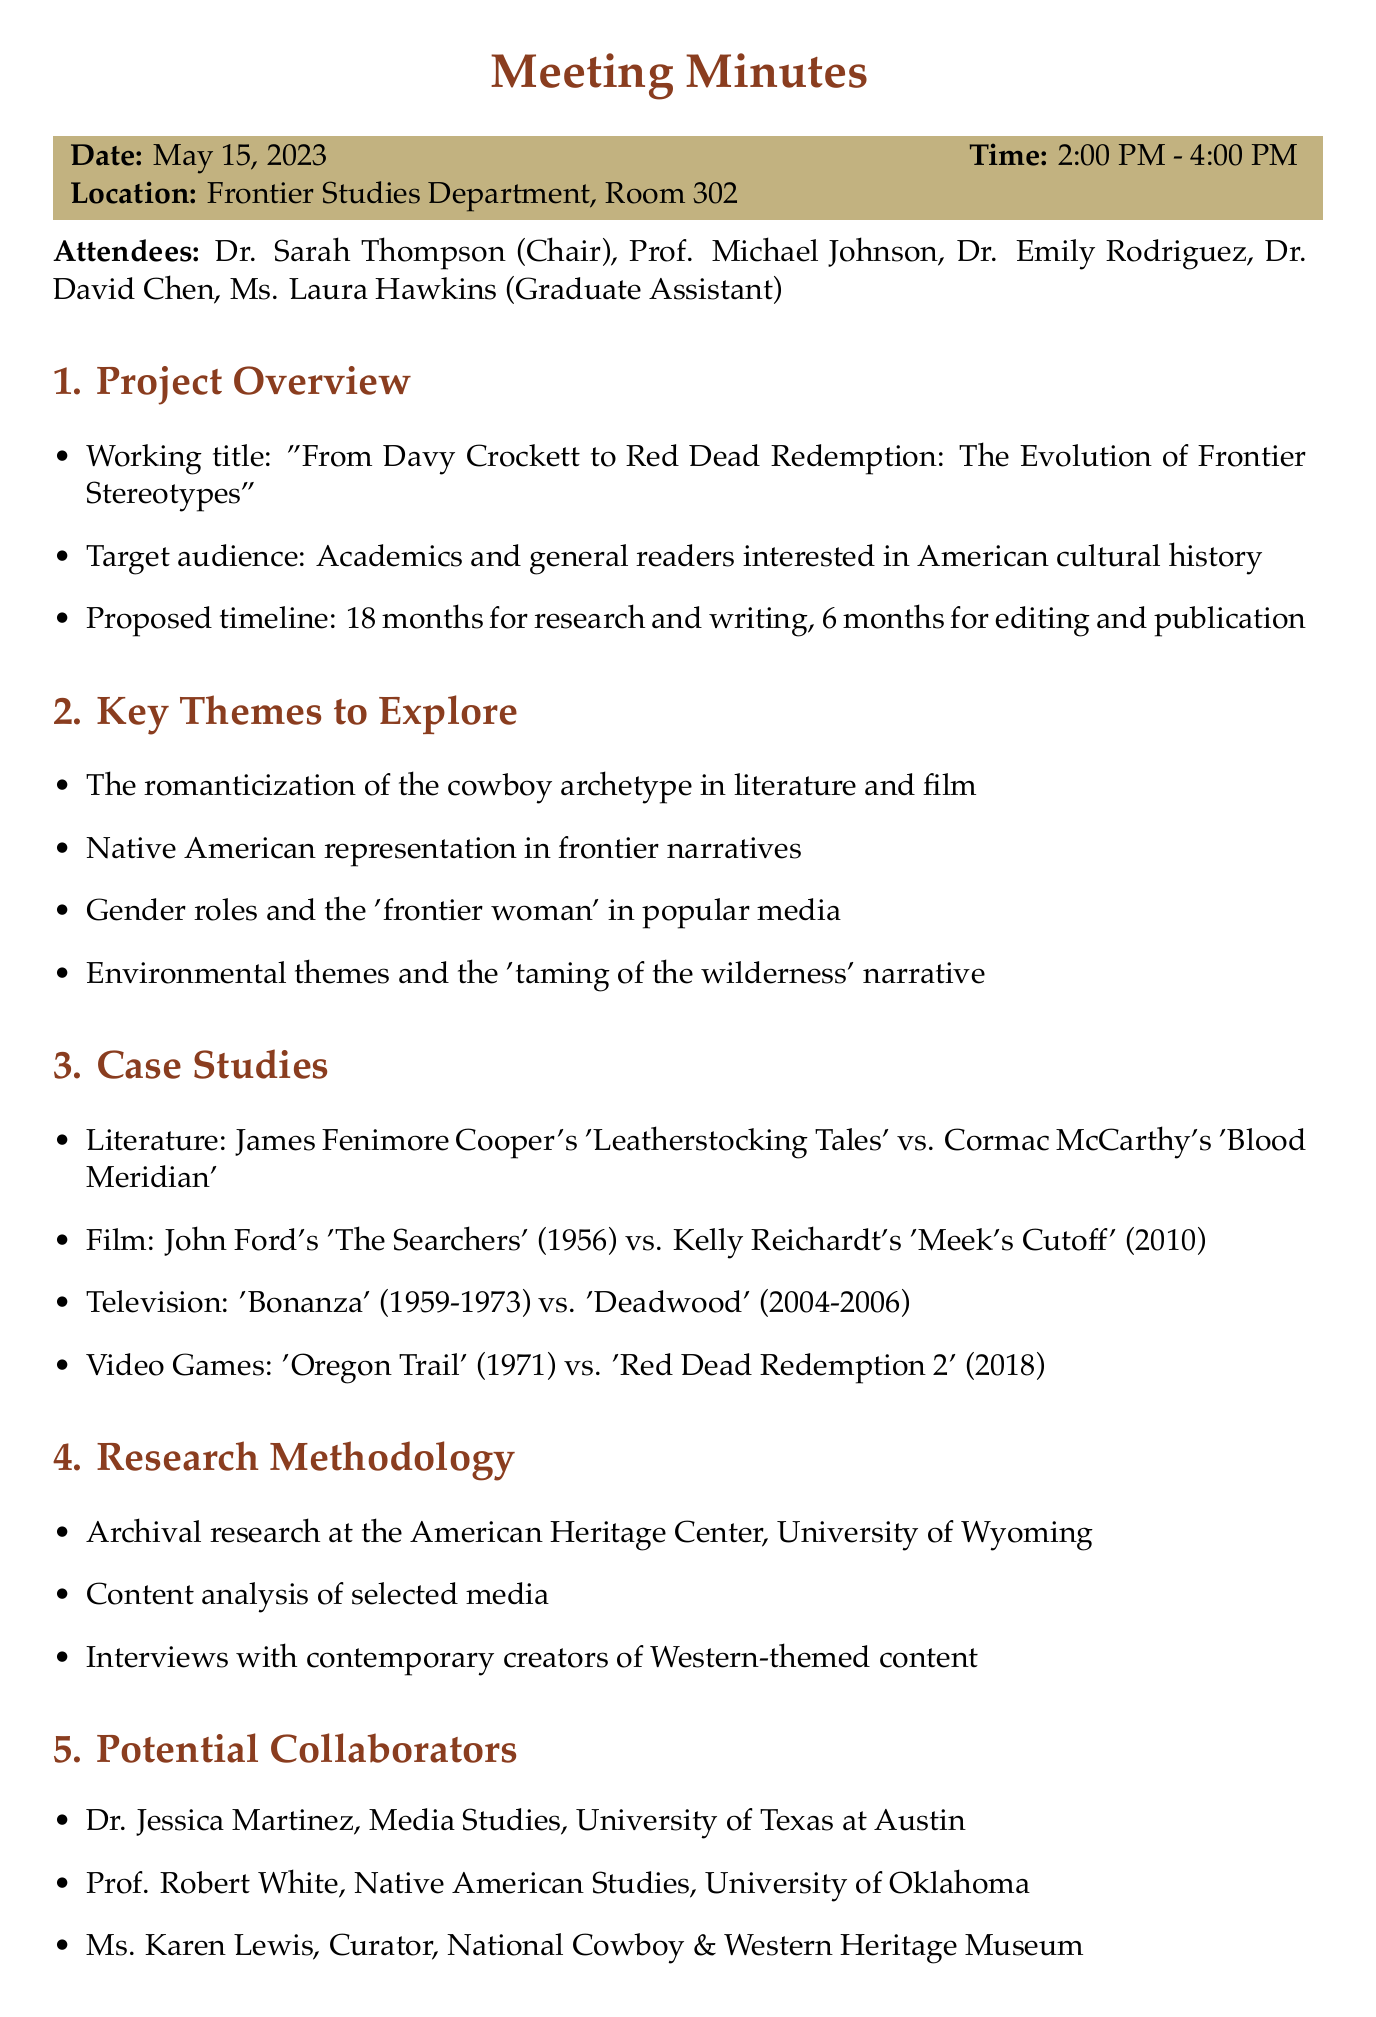What is the date of the meeting? The date of the meeting is explicitly mentioned at the beginning of the document.
Answer: May 15, 2023 Who is the chair of the meeting? The document lists Dr. Sarah Thompson as the chair in the attendee section.
Answer: Dr. Sarah Thompson What is the working title of the project? The working title is provided under the project overview section of the minutes.
Answer: From Davy Crockett to Red Dead Redemption: The Evolution of Frontier Stereotypes How long is the proposed timeline for research and writing? The timeline for research and writing is included in the project overview section.
Answer: 18 months Which two video games are mentioned as case studies? The case studies include specific video games in the relevant section of the document.
Answer: Oregon Trail vs. Red Dead Redemption 2 What is one key theme to explore regarding gender roles? The document identifies themes to explore, including gender-related ones.
Answer: 'frontier woman' in popular media How will progress meetings be scheduled? The next steps identified in the document specify how progress meetings will be organized.
Answer: Monthly progress meetings Who are two potential collaborators listed in the document? The potential collaborators are specified under their own section in the minutes.
Answer: Dr. Jessica Martinez, Prof. Robert White 